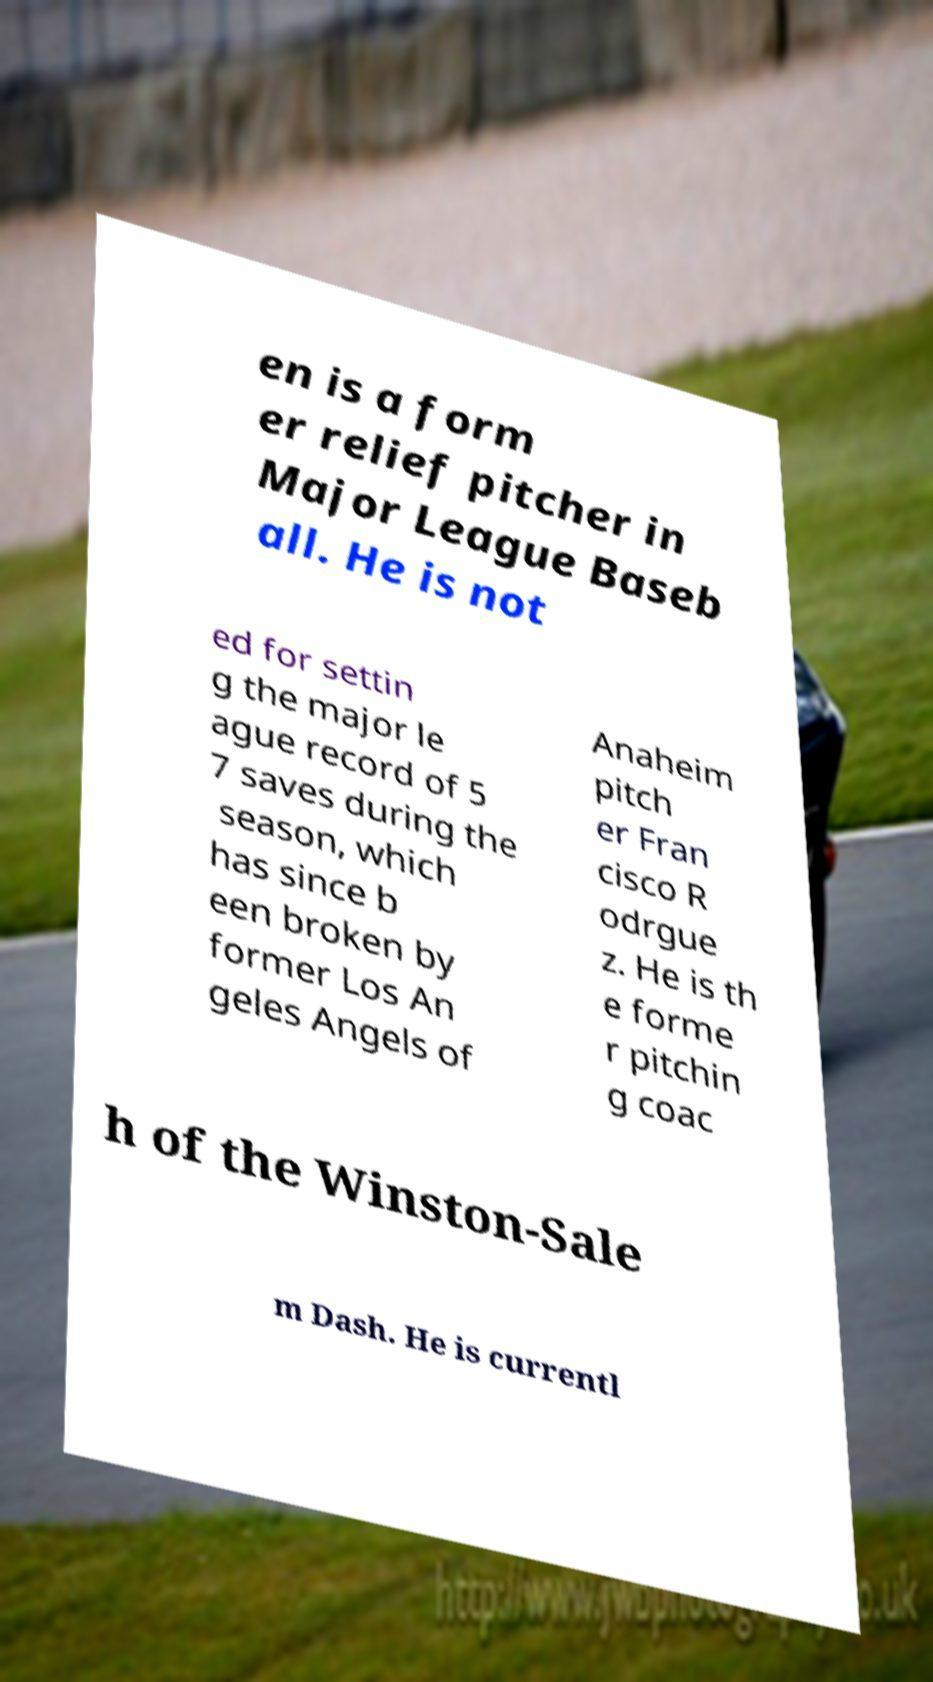What messages or text are displayed in this image? I need them in a readable, typed format. en is a form er relief pitcher in Major League Baseb all. He is not ed for settin g the major le ague record of 5 7 saves during the season, which has since b een broken by former Los An geles Angels of Anaheim pitch er Fran cisco R odrgue z. He is th e forme r pitchin g coac h of the Winston-Sale m Dash. He is currentl 